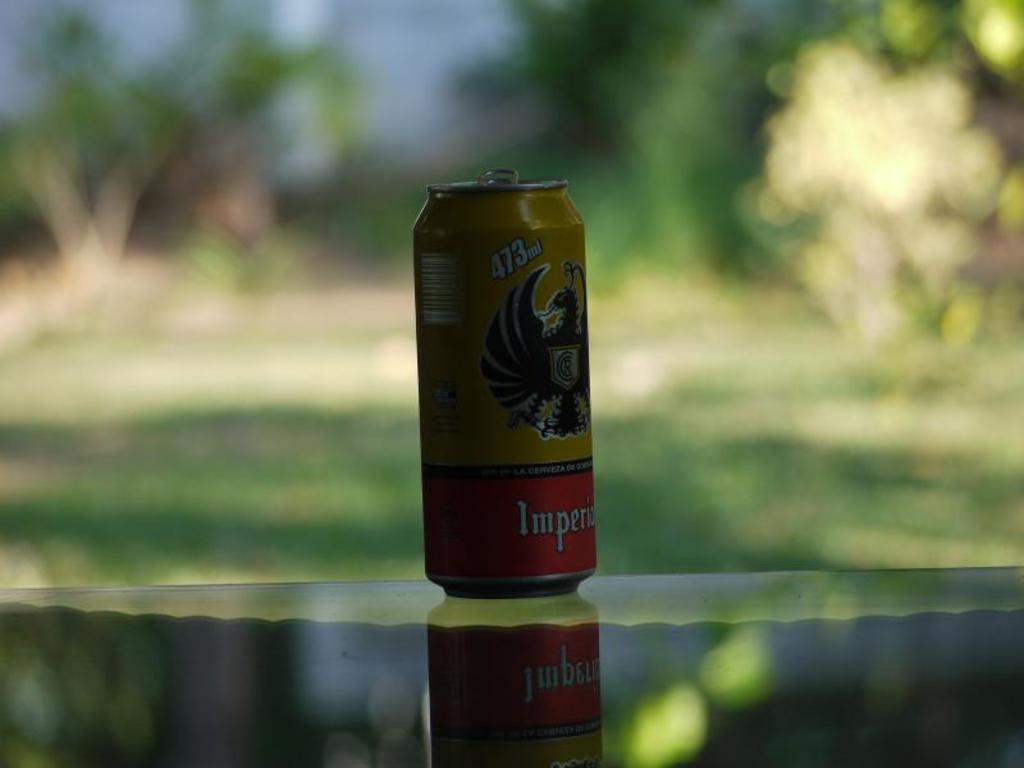What object is the main focus of the image? There is a tin in the image. Can you describe the background of the image? The background of the image is blurry. How many feathers can be seen in the image? There are no feathers present in the image. What action is being performed with the tin in the image? The image does not show any action being performed with the tin; it is simply a static object in the image. 